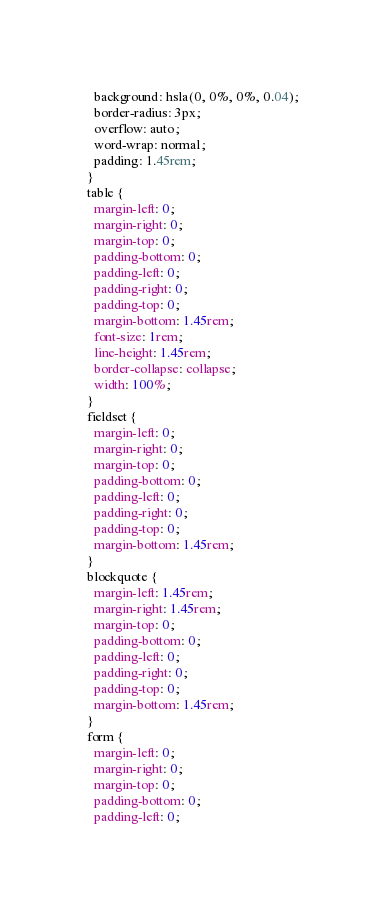Convert code to text. <code><loc_0><loc_0><loc_500><loc_500><_CSS_>  background: hsla(0, 0%, 0%, 0.04);
  border-radius: 3px;
  overflow: auto;
  word-wrap: normal;
  padding: 1.45rem;
}
table {
  margin-left: 0;
  margin-right: 0;
  margin-top: 0;
  padding-bottom: 0;
  padding-left: 0;
  padding-right: 0;
  padding-top: 0;
  margin-bottom: 1.45rem;
  font-size: 1rem;
  line-height: 1.45rem;
  border-collapse: collapse;
  width: 100%;
}
fieldset {
  margin-left: 0;
  margin-right: 0;
  margin-top: 0;
  padding-bottom: 0;
  padding-left: 0;
  padding-right: 0;
  padding-top: 0;
  margin-bottom: 1.45rem;
}
blockquote {
  margin-left: 1.45rem;
  margin-right: 1.45rem;
  margin-top: 0;
  padding-bottom: 0;
  padding-left: 0;
  padding-right: 0;
  padding-top: 0;
  margin-bottom: 1.45rem;
}
form {
  margin-left: 0;
  margin-right: 0;
  margin-top: 0;
  padding-bottom: 0;
  padding-left: 0;</code> 